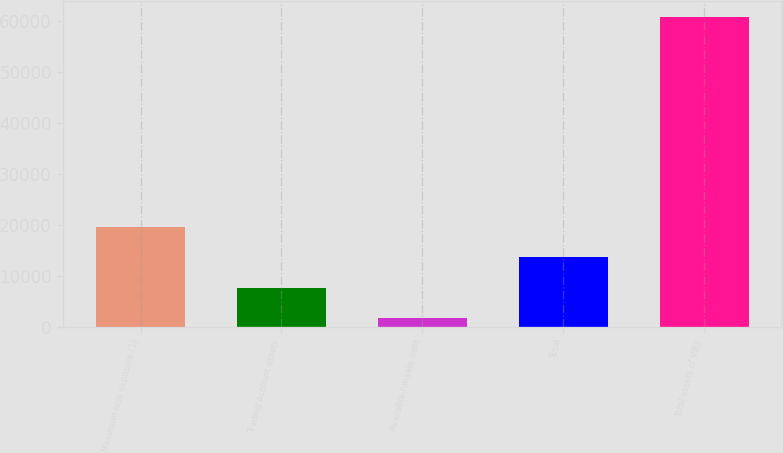Convert chart to OTSL. <chart><loc_0><loc_0><loc_500><loc_500><bar_chart><fcel>Maximum loss exposure (1)<fcel>Trading account assets<fcel>Available-for-sale debt<fcel>Total<fcel>Total assets of VIEs<nl><fcel>19484.1<fcel>7682.7<fcel>1782<fcel>13583.4<fcel>60789<nl></chart> 